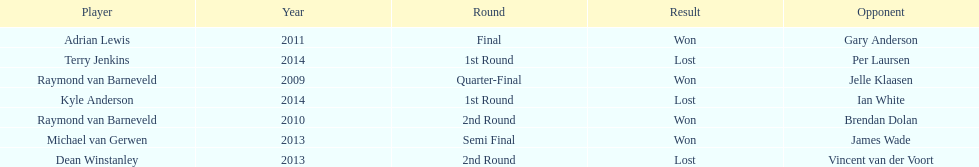Who was the last to win against his opponent? Michael van Gerwen. 